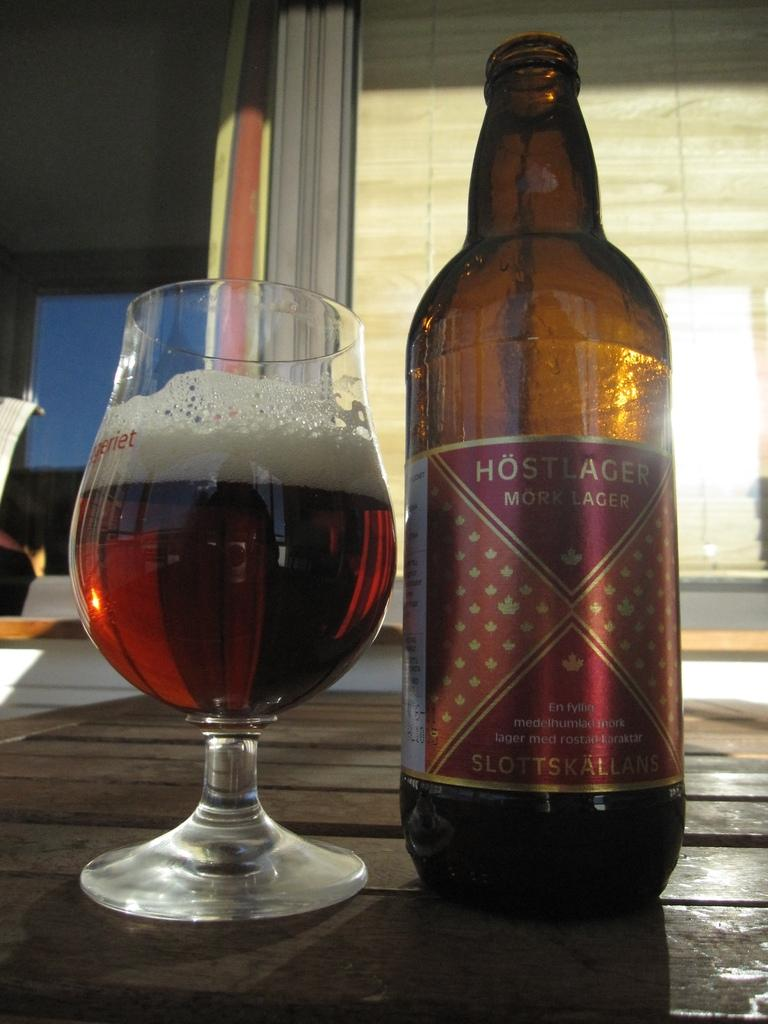What is on the table in the image? There is a wine bottle and a glass with wine on the table. What is in the glass? The glass contains wine. What can be seen in the background of the image? There is a window visible in the background. What type of selection is available in the wine glass? There is no selection available in the wine glass; it contains wine. What is the source of shame in the image? There is no indication of shame in the image. 